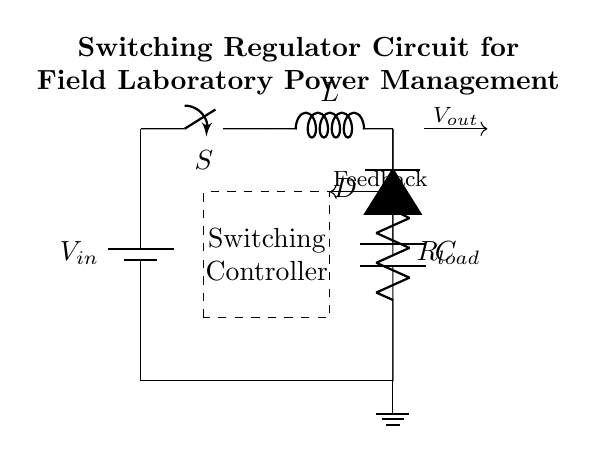What type of regulator is shown in the circuit? The circuit is a switching regulator, indicated by the presence of a switch, inductor, and diode for controlling the output voltage efficiently.
Answer: switching What is the role of the inductor in this circuit? The inductor stores energy when the switch is closed and releases it when the switch is open, helping to maintain a steady output voltage.
Answer: energy storage How many main components are present in the regulator circuit? The main components comprise a battery, switch, inductor, diode, capacitor, and load resistor, totaling six key components in the circuit.
Answer: six What component provides feedback in the circuit? The feedback mechanism is provided by the signal that returns from the output side to the control block, ensuring stability and proper output voltage regulation.
Answer: feedback What does the capacitor do in a switching regulator circuit? The capacitor smooths the output voltage by filtering out voltage ripples that occur during switching, ensuring a more stable DC output.
Answer: smooth output What is the function of the switch when it's closed? When closed, the switch allows current to flow through the inductor, enabling it to store energy for later use in the circuit.
Answer: store energy 